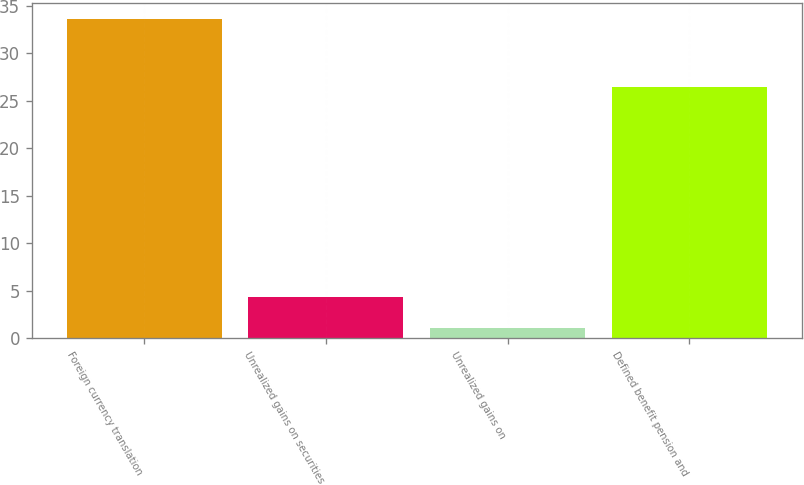Convert chart to OTSL. <chart><loc_0><loc_0><loc_500><loc_500><bar_chart><fcel>Foreign currency translation<fcel>Unrealized gains on securities<fcel>Unrealized gains on<fcel>Defined benefit pension and<nl><fcel>33.6<fcel>4.35<fcel>1.1<fcel>26.4<nl></chart> 